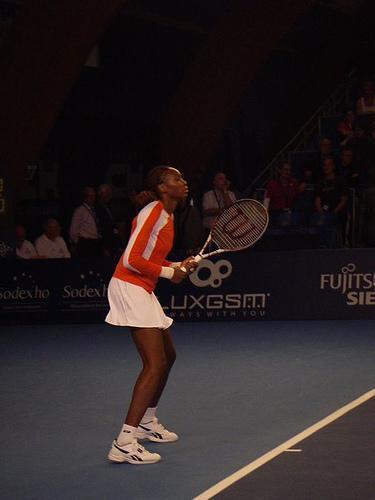How many women are in this scene?
Give a very brief answer. 1. How many elephants are facing the camera?
Give a very brief answer. 0. 